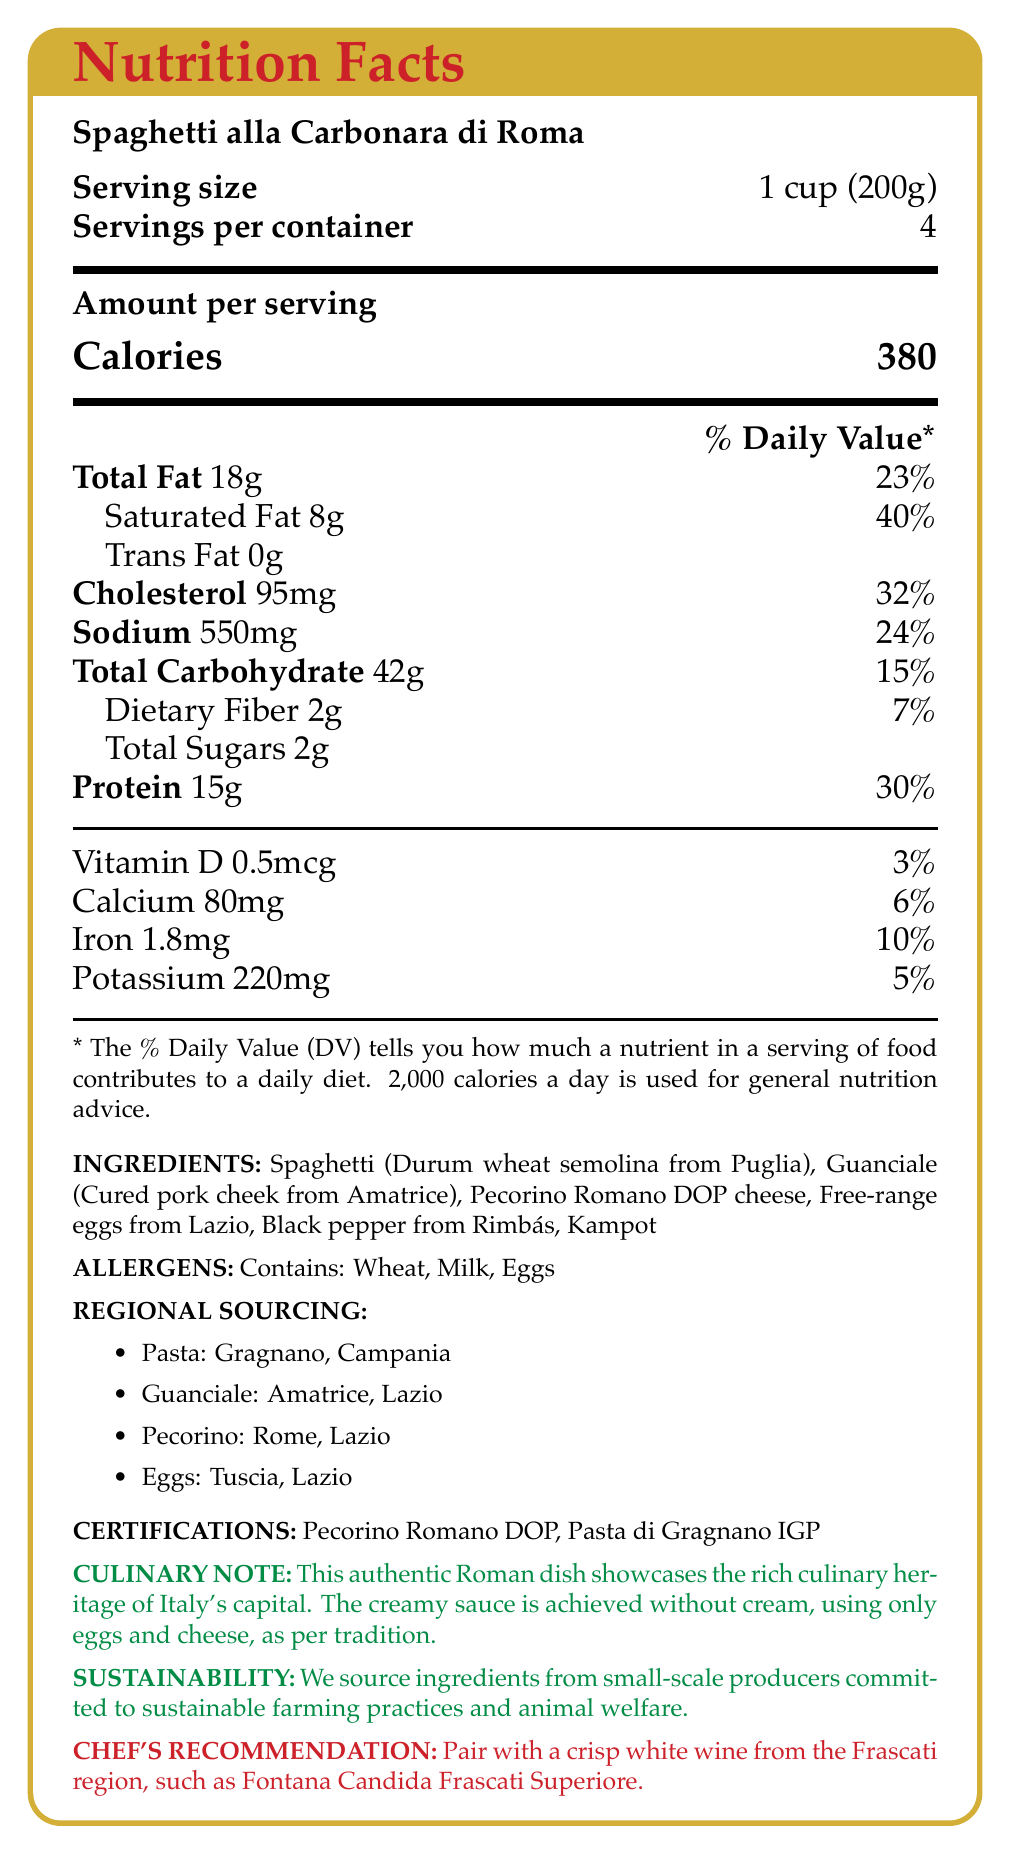what is the serving size of Spaghetti alla Carbonara di Roma? The document states the serving size is "1 cup (200g)" in the section labeled "Serving size".
Answer: 1 cup (200g) how many servings are there per container? The document mentions "Servings per container: 4".
Answer: 4 what is the total fat content per serving? The section stating "Total Fat" lists 18g per serving.
Answer: 18g how much sodium is in one serving? The "Sodium" content per serving is listed as 550mg in the nutrition facts.
Answer: 550mg what is the daily value percentage of saturated fat per serving? According to the document, the "Saturated Fat" daily value percentage is 40%.
Answer: 40% Which country is the black pepper from? A. Italy B. India C. Cambodia D. Vietnam The document mentions that the black pepper is from "Rimbás, Kampot," which is in Cambodia.
Answer: C. Cambodia How many grams of dietary fiber are in each serving? A. 1g B. 2g C. 3g D. 4g The "Dietary Fiber" per serving is listed as 2g.
Answer: B. 2g Does the document certify any ingredients? (Yes/No) The document lists certifications "Pecorino Romano DOP" and "Pasta di Gragnano IGP".
Answer: Yes what are the main allergens listed? The document states under "ALLERGENS" that it contains Wheat, Milk, and Eggs.
Answer: Wheat, Milk, Eggs where is the guanciale sourced from? The "regional sourcing" section says the guanciale is from Amatrice, Lazio.
Answer: Amatrice, Lazio Describe the main idea of the document. The document's main idea is to inform the reader about the nutritional content, ingredients, sourcing, and additional qualifications and recommendations regarding the traditional Italian dish Spaghetti alla Carbonara di Roma.
Answer: The document provides detailed nutritional information, ingredients, regional sourcing, and additional notes for Spaghetti alla Carbonara di Roma. It highlights its authenticity and regional sourcing, lists allergens, and includes sustainability and culinary notes. What is the sustainability focus mentioned in the document? The document states, "We source ingredients from small-scale producers committed to sustainable farming practices and animal welfare".
Answer: Sustainable farming practices and animal welfare How many calories are in one serving? The document mentions "Calories: 380" per serving in the Nutrition Facts section.
Answer: 380 Can you list the region from which the pasta is sourced? The regional sourcing section shows that the pasta is from Gragnano, Campania.
Answer: Gragnano, Campania what is the cholesterol content per serving? The document lists "Cholesterol: 95mg" per serving.
Answer: 95mg Where are the free-range eggs sourced from? The regional sourcing section specifies "eggs: Tuscia, Lazio".
Answer: Tuscia, Lazio What type of wine is recommended to pair with this dish? The chef's recommendation section mentions to pair it with "Fontana Candida Frascati Superiore".
Answer: Fontana Candida Frascati Superiore How much calcium is in one serving, and what is its daily value percentage? The document lists calcium content as "80mg" and its daily value percentage as "6%".
Answer: 80mg, 6% Is the total carbohydrate content per serving higher than the dietary fiber content? The document lists "Total Carbohydrate" as 42g and "Dietary Fiber" as 2g.
Answer: Yes what is the origin of durum wheat semolina used? The ingredients section lists "Durum wheat semolina from Puglia".
Answer: Puglia What is the vitamin D content per serving? The document shows "Vitamin D: 0.5mcg" per serving in the nutrition facts.
Answer: 0.5mcg How is the creamy sauce for Spaghetti alla Carbonara di Roma achieved, according to the culinary note? The culinary note mentions, "The creamy sauce is achieved without cream, using only eggs and cheese".
Answer: Using only eggs and cheese How much protein is in one serving, and what is its daily value percentage? The document lists protein content per serving as "15g" and its daily value percentage as "30%".
Answer: 15g, 30% What is the exact amount of iron per serving? The document specifies "Iron: 1.8mg" per serving.
Answer: 1.8mg Is this dish suitable for a vegan diet? The document lists ingredients such as guanciale (pork cheek), Pecorino Romano cheese, and eggs, which are not suitable for a vegan diet.
Answer: No What is the total sugar content per serving? The document mentions the "Total Sugars: 2g" per serving.
Answer: 2g Where is the Pecorino Romano cheese from? The regional sourcing section mentions "pecorino: Rome, Lazio".
Answer: Rome, Lazio Are there any regional certifications for the ingredients listed? The document certifies "Pecorino Romano DOP" and "Pasta di Gragnano IGP".
Answer: Yes you want to know the detailed recipe for Spaghetti alla Carbonara di Roma, including preparation steps. The document provides nutritional facts, ingredient sourcing, and other culinary notes but does not provide a detailed recipe with preparation steps.
Answer: Not enough information 